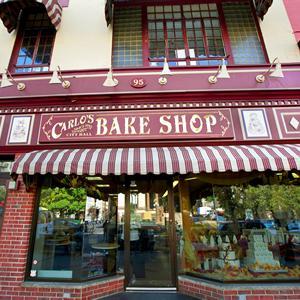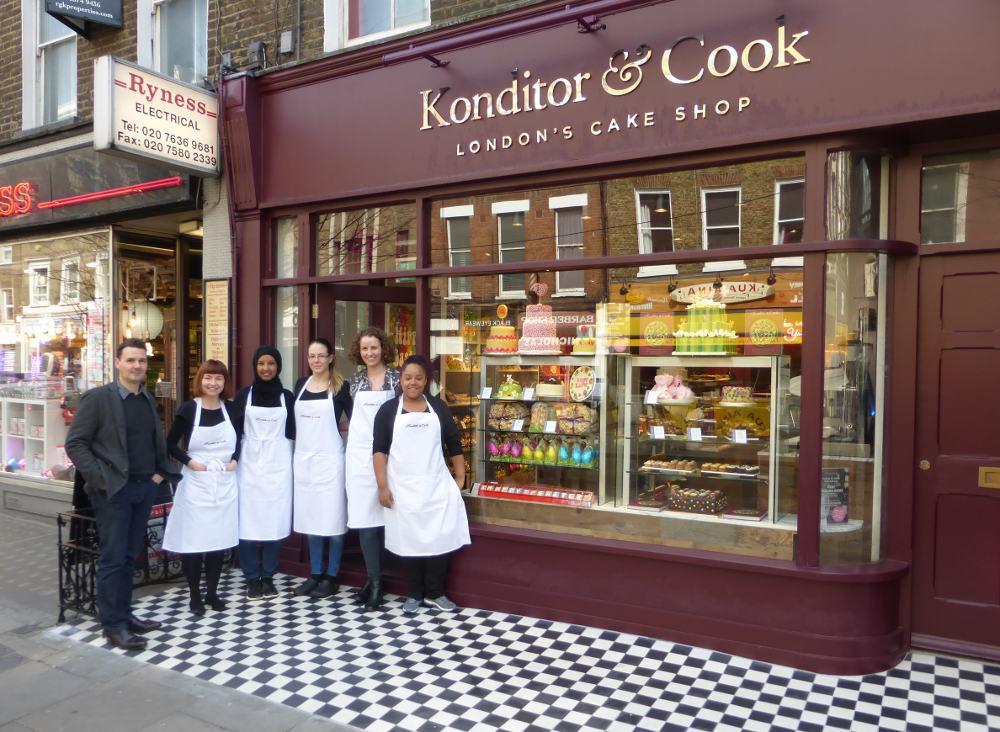The first image is the image on the left, the second image is the image on the right. Assess this claim about the two images: "There is a man with his  palms facing up.". Correct or not? Answer yes or no. No. 